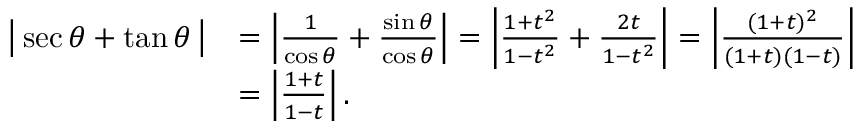<formula> <loc_0><loc_0><loc_500><loc_500>{ \begin{array} { r l } { { \left | } \sec \theta + \tan \theta \, { \right | } } & { = \left | { \frac { 1 } { \cos \theta } } + { \frac { \sin \theta } { \cos \theta } } \right | = \left | { \frac { 1 + t ^ { 2 } } { 1 - t ^ { 2 } } } + { \frac { 2 t } { 1 - t ^ { 2 } } } \right | = \left | { \frac { ( 1 + t ) ^ { 2 } } { ( 1 + t ) ( 1 - t ) } } \right | } \\ & { = \left | { \frac { 1 + t } { 1 - t } } \right | . } \end{array} }</formula> 